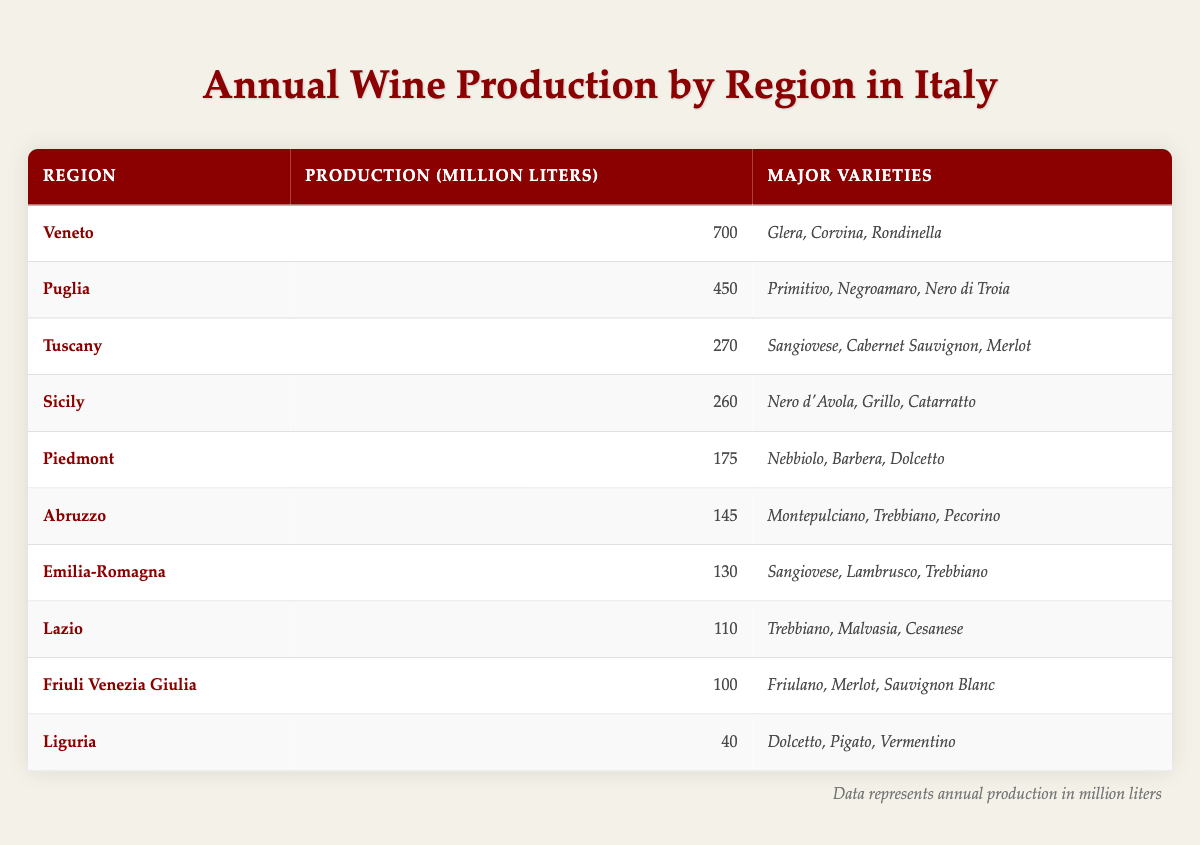What region produces the most wine in Italy? By examining the table, we see that Veneto has the highest production at 700 million liters.
Answer: Veneto Which region has the least wine production? Looking at the table, Liguria has the lowest production, with only 40 million liters.
Answer: Liguria How much wine does Tuscany produce compared to Puglia? Tuscany produces 270 million liters while Puglia produces 450 million liters. The difference is 450 - 270 = 180 million liters.
Answer: 180 million liters What are the major wine varieties produced in Sicily? According to the table, the major varieties in Sicily are Nero d'Avola, Grillo, and Catarratto.
Answer: Nero d'Avola, Grillo, Catarratto True or False: Puglia produces more wine than Piedmont. The table shows Puglia producing 450 million liters while Piedmont produces 175 million liters. Thus, it is true that Puglia produces more wine than Piedmont.
Answer: True What is the total wine production of Tuscany and Abruzzo combined? From the table, Tuscany produces 270 million liters and Abruzzo produces 145 million liters. Adding these gives us 270 + 145 = 415 million liters.
Answer: 415 million liters Which regions produce Sangiovese as a major variety? The table lists Sangiovese as a major variety in both Tuscany and Emilia-Romagna.
Answer: Tuscany, Emilia-Romagna If we mix the production of Lazio and Friuli Venezia Giulia, how much wine do they produce together? Lazio produces 110 million liters and Friuli Venezia Giulia produces 100 million liters. Their combined production is 110 + 100 = 210 million liters.
Answer: 210 million liters What is the average wine production of the regions listed? The table presents data for 10 regions. The total production is 270 + 175 + 700 + 260 + 110 + 130 + 145 + 450 + 40 + 100 = 1880 million liters. Dividing this by 10 regions, the average is 1880 / 10 = 188 million liters.
Answer: 188 million liters Which region has the highest production among the southern regions? Looking at the table, Puglia has the highest production among the southern regions at 450 million liters.
Answer: Puglia 